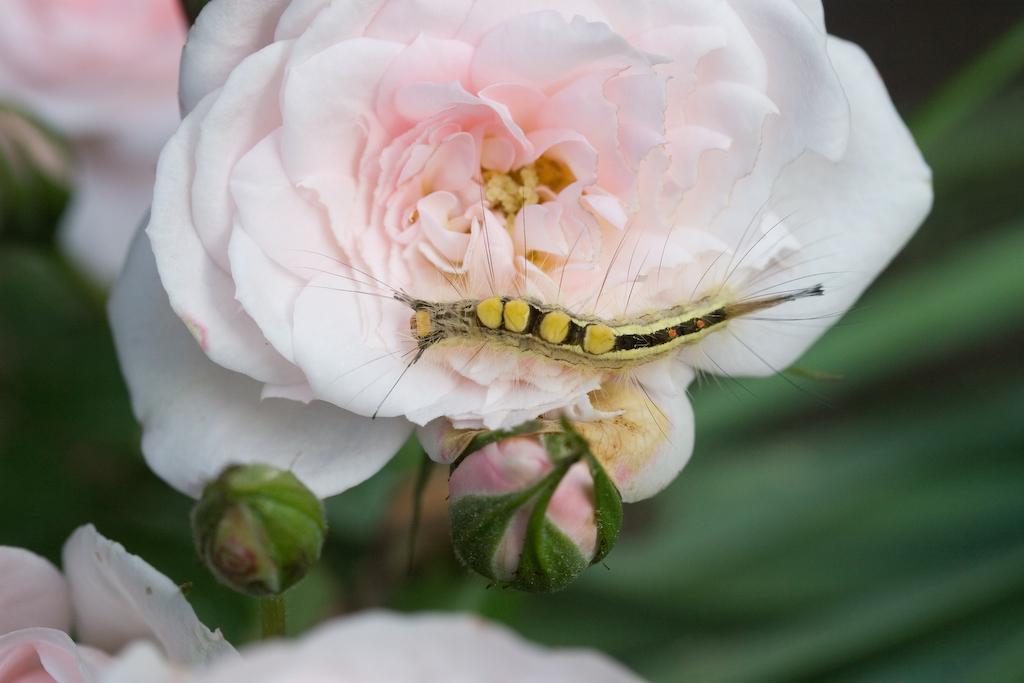Could you give a brief overview of what you see in this image? In this image there is an insect on the flower which is in the center and the background is blurry. 